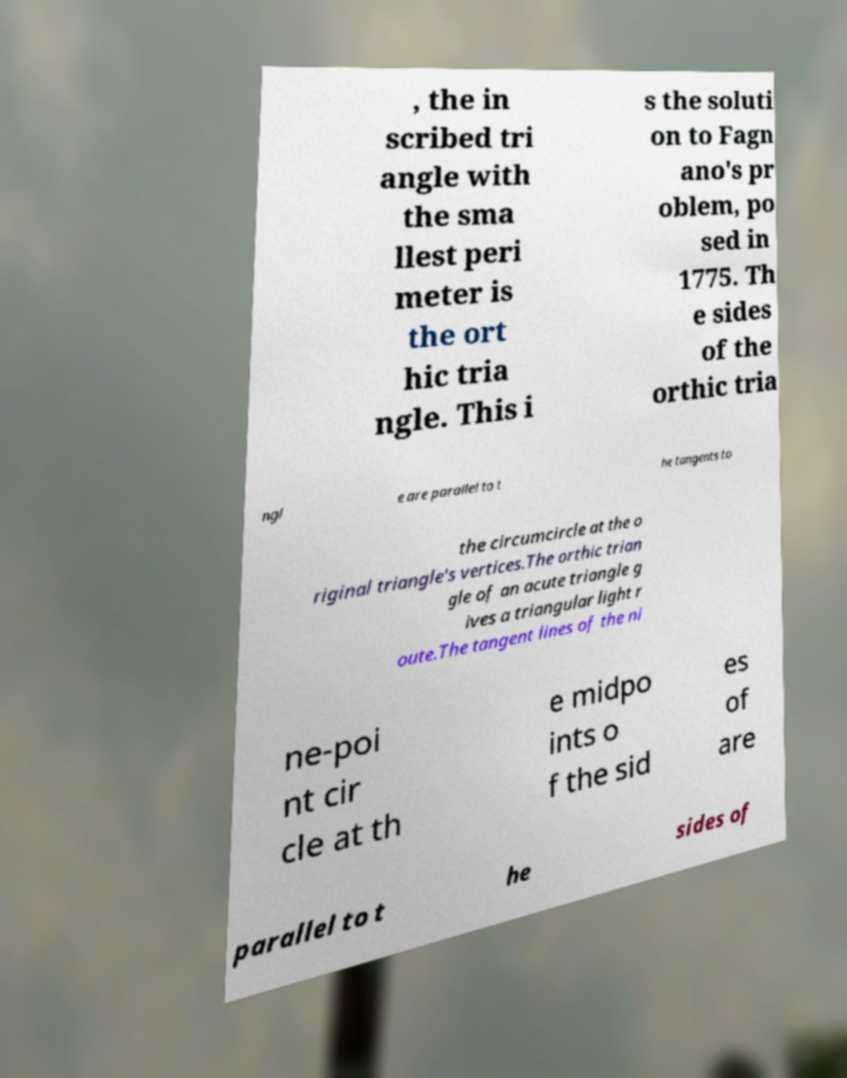Please identify and transcribe the text found in this image. , the in scribed tri angle with the sma llest peri meter is the ort hic tria ngle. This i s the soluti on to Fagn ano's pr oblem, po sed in 1775. Th e sides of the orthic tria ngl e are parallel to t he tangents to the circumcircle at the o riginal triangle's vertices.The orthic trian gle of an acute triangle g ives a triangular light r oute.The tangent lines of the ni ne-poi nt cir cle at th e midpo ints o f the sid es of are parallel to t he sides of 